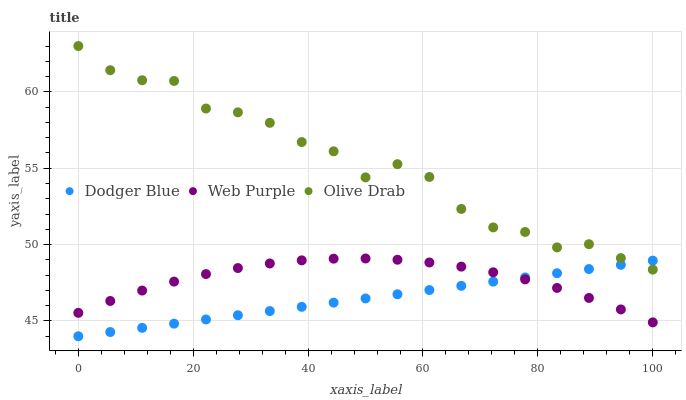Does Dodger Blue have the minimum area under the curve?
Answer yes or no. Yes. Does Olive Drab have the maximum area under the curve?
Answer yes or no. Yes. Does Olive Drab have the minimum area under the curve?
Answer yes or no. No. Does Dodger Blue have the maximum area under the curve?
Answer yes or no. No. Is Dodger Blue the smoothest?
Answer yes or no. Yes. Is Olive Drab the roughest?
Answer yes or no. Yes. Is Olive Drab the smoothest?
Answer yes or no. No. Is Dodger Blue the roughest?
Answer yes or no. No. Does Dodger Blue have the lowest value?
Answer yes or no. Yes. Does Olive Drab have the lowest value?
Answer yes or no. No. Does Olive Drab have the highest value?
Answer yes or no. Yes. Does Dodger Blue have the highest value?
Answer yes or no. No. Is Web Purple less than Olive Drab?
Answer yes or no. Yes. Is Olive Drab greater than Web Purple?
Answer yes or no. Yes. Does Olive Drab intersect Dodger Blue?
Answer yes or no. Yes. Is Olive Drab less than Dodger Blue?
Answer yes or no. No. Is Olive Drab greater than Dodger Blue?
Answer yes or no. No. Does Web Purple intersect Olive Drab?
Answer yes or no. No. 